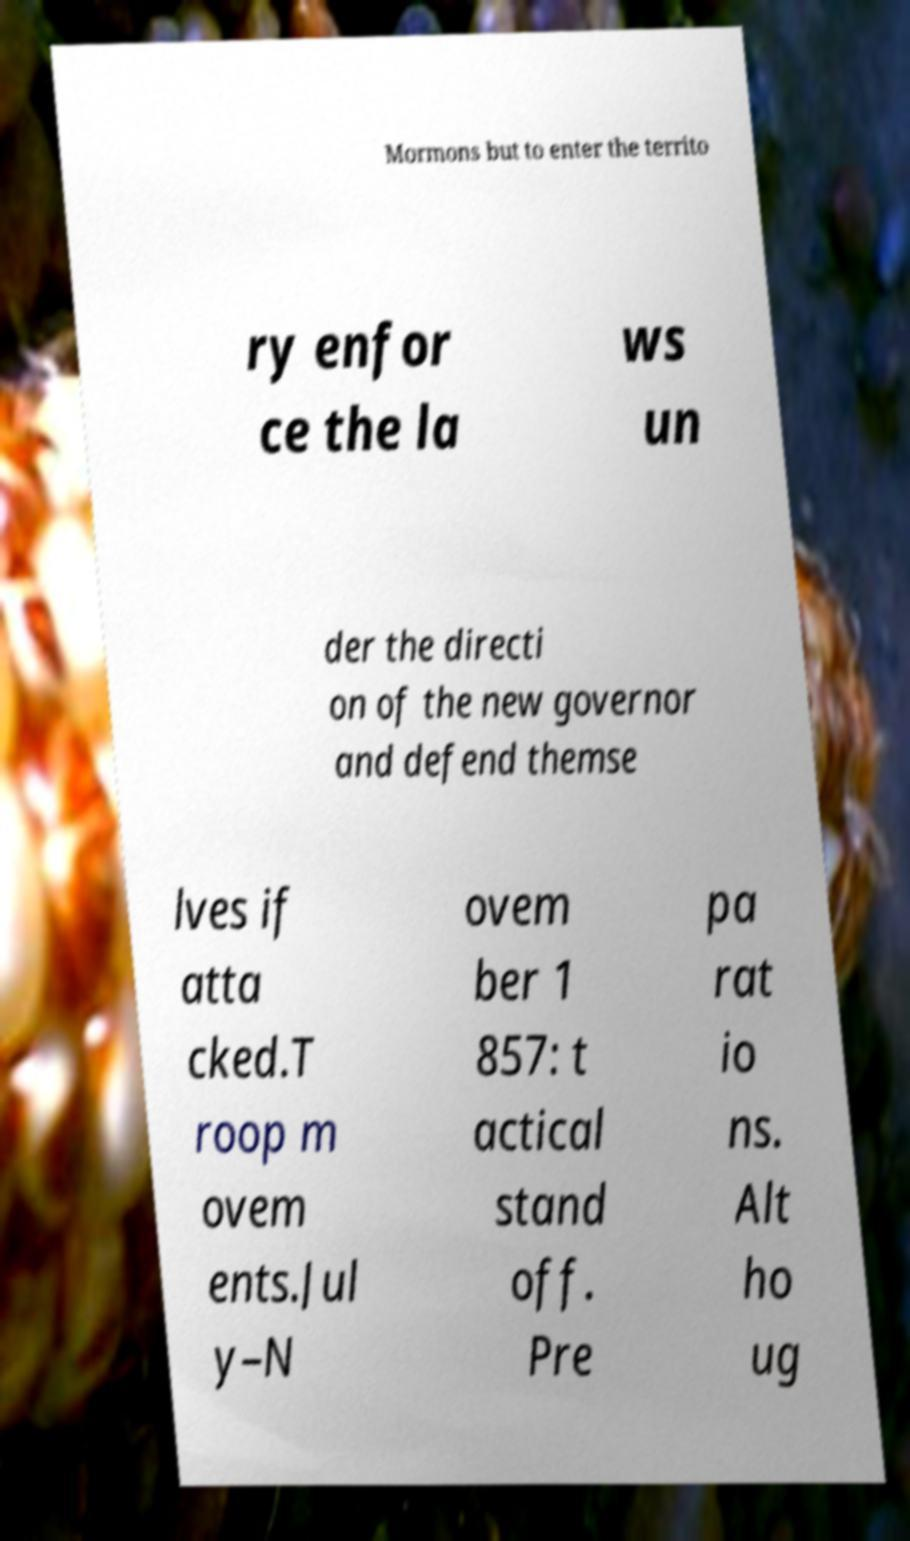Could you extract and type out the text from this image? Mormons but to enter the territo ry enfor ce the la ws un der the directi on of the new governor and defend themse lves if atta cked.T roop m ovem ents.Jul y–N ovem ber 1 857: t actical stand off. Pre pa rat io ns. Alt ho ug 